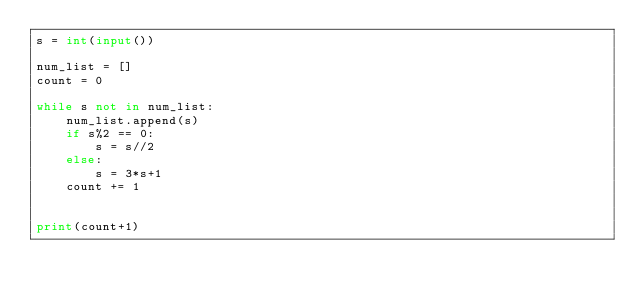Convert code to text. <code><loc_0><loc_0><loc_500><loc_500><_Python_>s = int(input())

num_list = []
count = 0

while s not in num_list:
    num_list.append(s)
    if s%2 == 0:
        s = s//2
    else:
        s = 3*s+1
    count += 1
    

print(count+1)</code> 